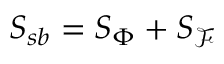Convert formula to latex. <formula><loc_0><loc_0><loc_500><loc_500>\begin{array} { r } { S _ { s b } = S _ { \Phi } + S _ { \mathcal { F } } } \end{array}</formula> 